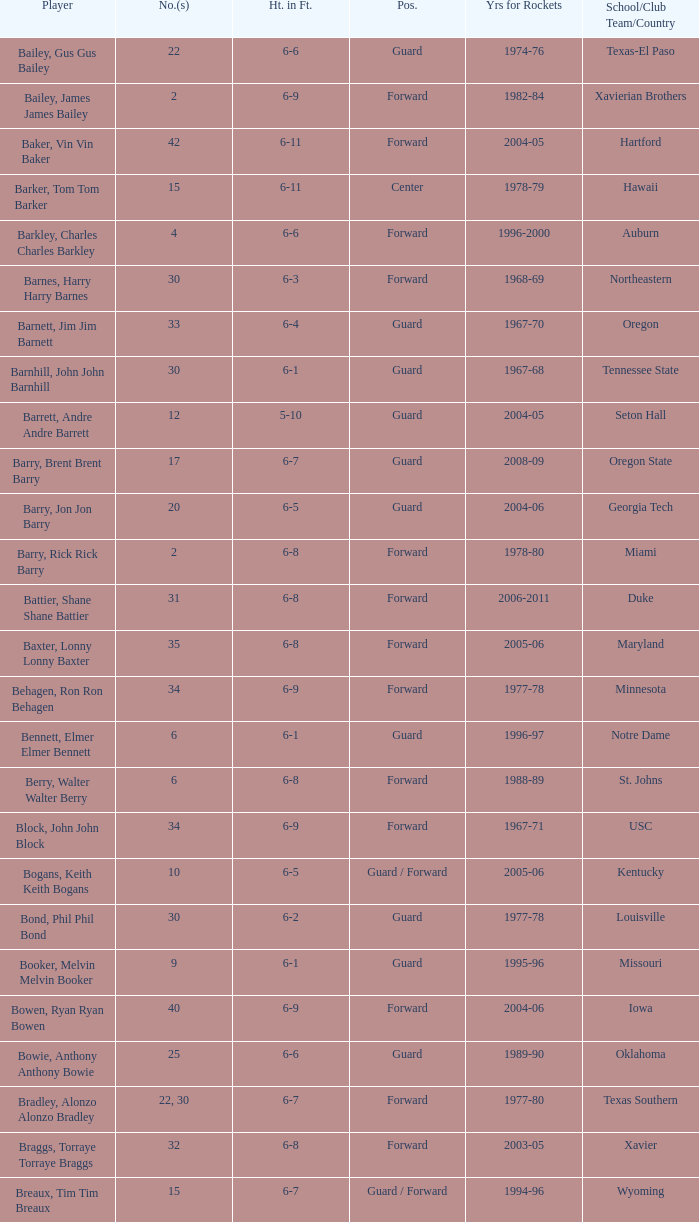What position is number 35 whose height is 6-6? Forward. Help me parse the entirety of this table. {'header': ['Player', 'No.(s)', 'Ht. in Ft.', 'Pos.', 'Yrs for Rockets', 'School/Club Team/Country'], 'rows': [['Bailey, Gus Gus Bailey', '22', '6-6', 'Guard', '1974-76', 'Texas-El Paso'], ['Bailey, James James Bailey', '2', '6-9', 'Forward', '1982-84', 'Xavierian Brothers'], ['Baker, Vin Vin Baker', '42', '6-11', 'Forward', '2004-05', 'Hartford'], ['Barker, Tom Tom Barker', '15', '6-11', 'Center', '1978-79', 'Hawaii'], ['Barkley, Charles Charles Barkley', '4', '6-6', 'Forward', '1996-2000', 'Auburn'], ['Barnes, Harry Harry Barnes', '30', '6-3', 'Forward', '1968-69', 'Northeastern'], ['Barnett, Jim Jim Barnett', '33', '6-4', 'Guard', '1967-70', 'Oregon'], ['Barnhill, John John Barnhill', '30', '6-1', 'Guard', '1967-68', 'Tennessee State'], ['Barrett, Andre Andre Barrett', '12', '5-10', 'Guard', '2004-05', 'Seton Hall'], ['Barry, Brent Brent Barry', '17', '6-7', 'Guard', '2008-09', 'Oregon State'], ['Barry, Jon Jon Barry', '20', '6-5', 'Guard', '2004-06', 'Georgia Tech'], ['Barry, Rick Rick Barry', '2', '6-8', 'Forward', '1978-80', 'Miami'], ['Battier, Shane Shane Battier', '31', '6-8', 'Forward', '2006-2011', 'Duke'], ['Baxter, Lonny Lonny Baxter', '35', '6-8', 'Forward', '2005-06', 'Maryland'], ['Behagen, Ron Ron Behagen', '34', '6-9', 'Forward', '1977-78', 'Minnesota'], ['Bennett, Elmer Elmer Bennett', '6', '6-1', 'Guard', '1996-97', 'Notre Dame'], ['Berry, Walter Walter Berry', '6', '6-8', 'Forward', '1988-89', 'St. Johns'], ['Block, John John Block', '34', '6-9', 'Forward', '1967-71', 'USC'], ['Bogans, Keith Keith Bogans', '10', '6-5', 'Guard / Forward', '2005-06', 'Kentucky'], ['Bond, Phil Phil Bond', '30', '6-2', 'Guard', '1977-78', 'Louisville'], ['Booker, Melvin Melvin Booker', '9', '6-1', 'Guard', '1995-96', 'Missouri'], ['Bowen, Ryan Ryan Bowen', '40', '6-9', 'Forward', '2004-06', 'Iowa'], ['Bowie, Anthony Anthony Bowie', '25', '6-6', 'Guard', '1989-90', 'Oklahoma'], ['Bradley, Alonzo Alonzo Bradley', '22, 30', '6-7', 'Forward', '1977-80', 'Texas Southern'], ['Braggs, Torraye Torraye Braggs', '32', '6-8', 'Forward', '2003-05', 'Xavier'], ['Breaux, Tim Tim Breaux', '15', '6-7', 'Guard / Forward', '1994-96', 'Wyoming'], ['Britt, Tyrone Tyrone Britt', '31', '6-4', 'Guard', '1967-68', 'Johnson C. Smith'], ['Brooks, Aaron Aaron Brooks', '0', '6-0', 'Guard', '2007-2011, 2013', 'Oregon'], ['Brooks, Scott Scott Brooks', '1', '5-11', 'Guard', '1992-95', 'UC-Irvine'], ['Brown, Chucky Chucky Brown', '52', '6-8', 'Forward', '1994-96', 'North Carolina'], ['Brown, Tony Tony Brown', '35', '6-6', 'Forward', '1988-89', 'Arkansas'], ['Brown, Tierre Tierre Brown', '10', '6-2', 'Guard', '2001-02', 'McNesse State'], ['Brunson, Rick Rick Brunson', '9', '6-4', 'Guard', '2005-06', 'Temple'], ['Bryant, Joe Joe Bryant', '22', '6-9', 'Forward / Guard', '1982-83', 'LaSalle'], ['Bryant, Mark Mark Bryant', '2', '6-9', 'Forward', '1995-96', 'Seton Hall'], ['Budinger, Chase Chase Budinger', '10', '6-7', 'Forward', '2009-2012', 'Arizona'], ['Bullard, Matt Matt Bullard', '50', '6-10', 'Forward', '1990-94, 1996-2001', 'Iowa']]} 